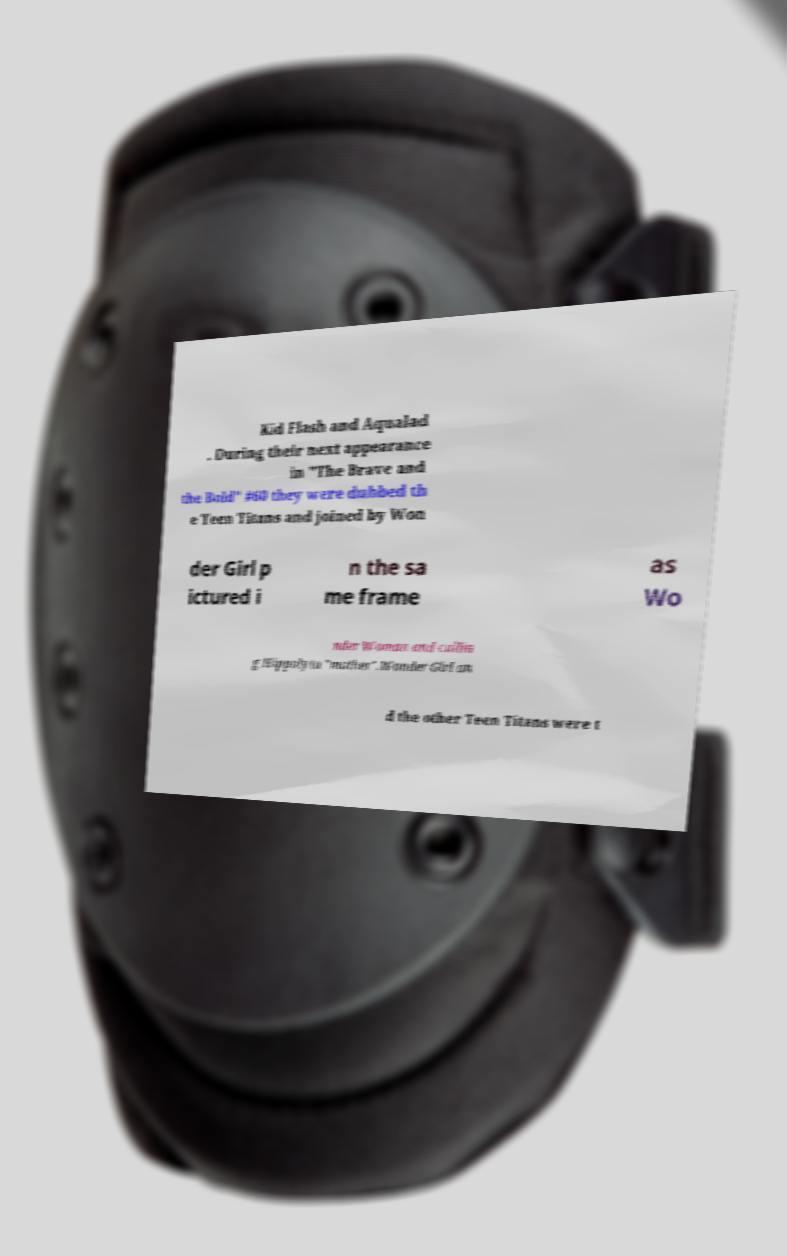There's text embedded in this image that I need extracted. Can you transcribe it verbatim? Kid Flash and Aqualad . During their next appearance in "The Brave and the Bold" #60 they were dubbed th e Teen Titans and joined by Won der Girl p ictured i n the sa me frame as Wo nder Woman and callin g Hippolyta "mother".Wonder Girl an d the other Teen Titans were t 